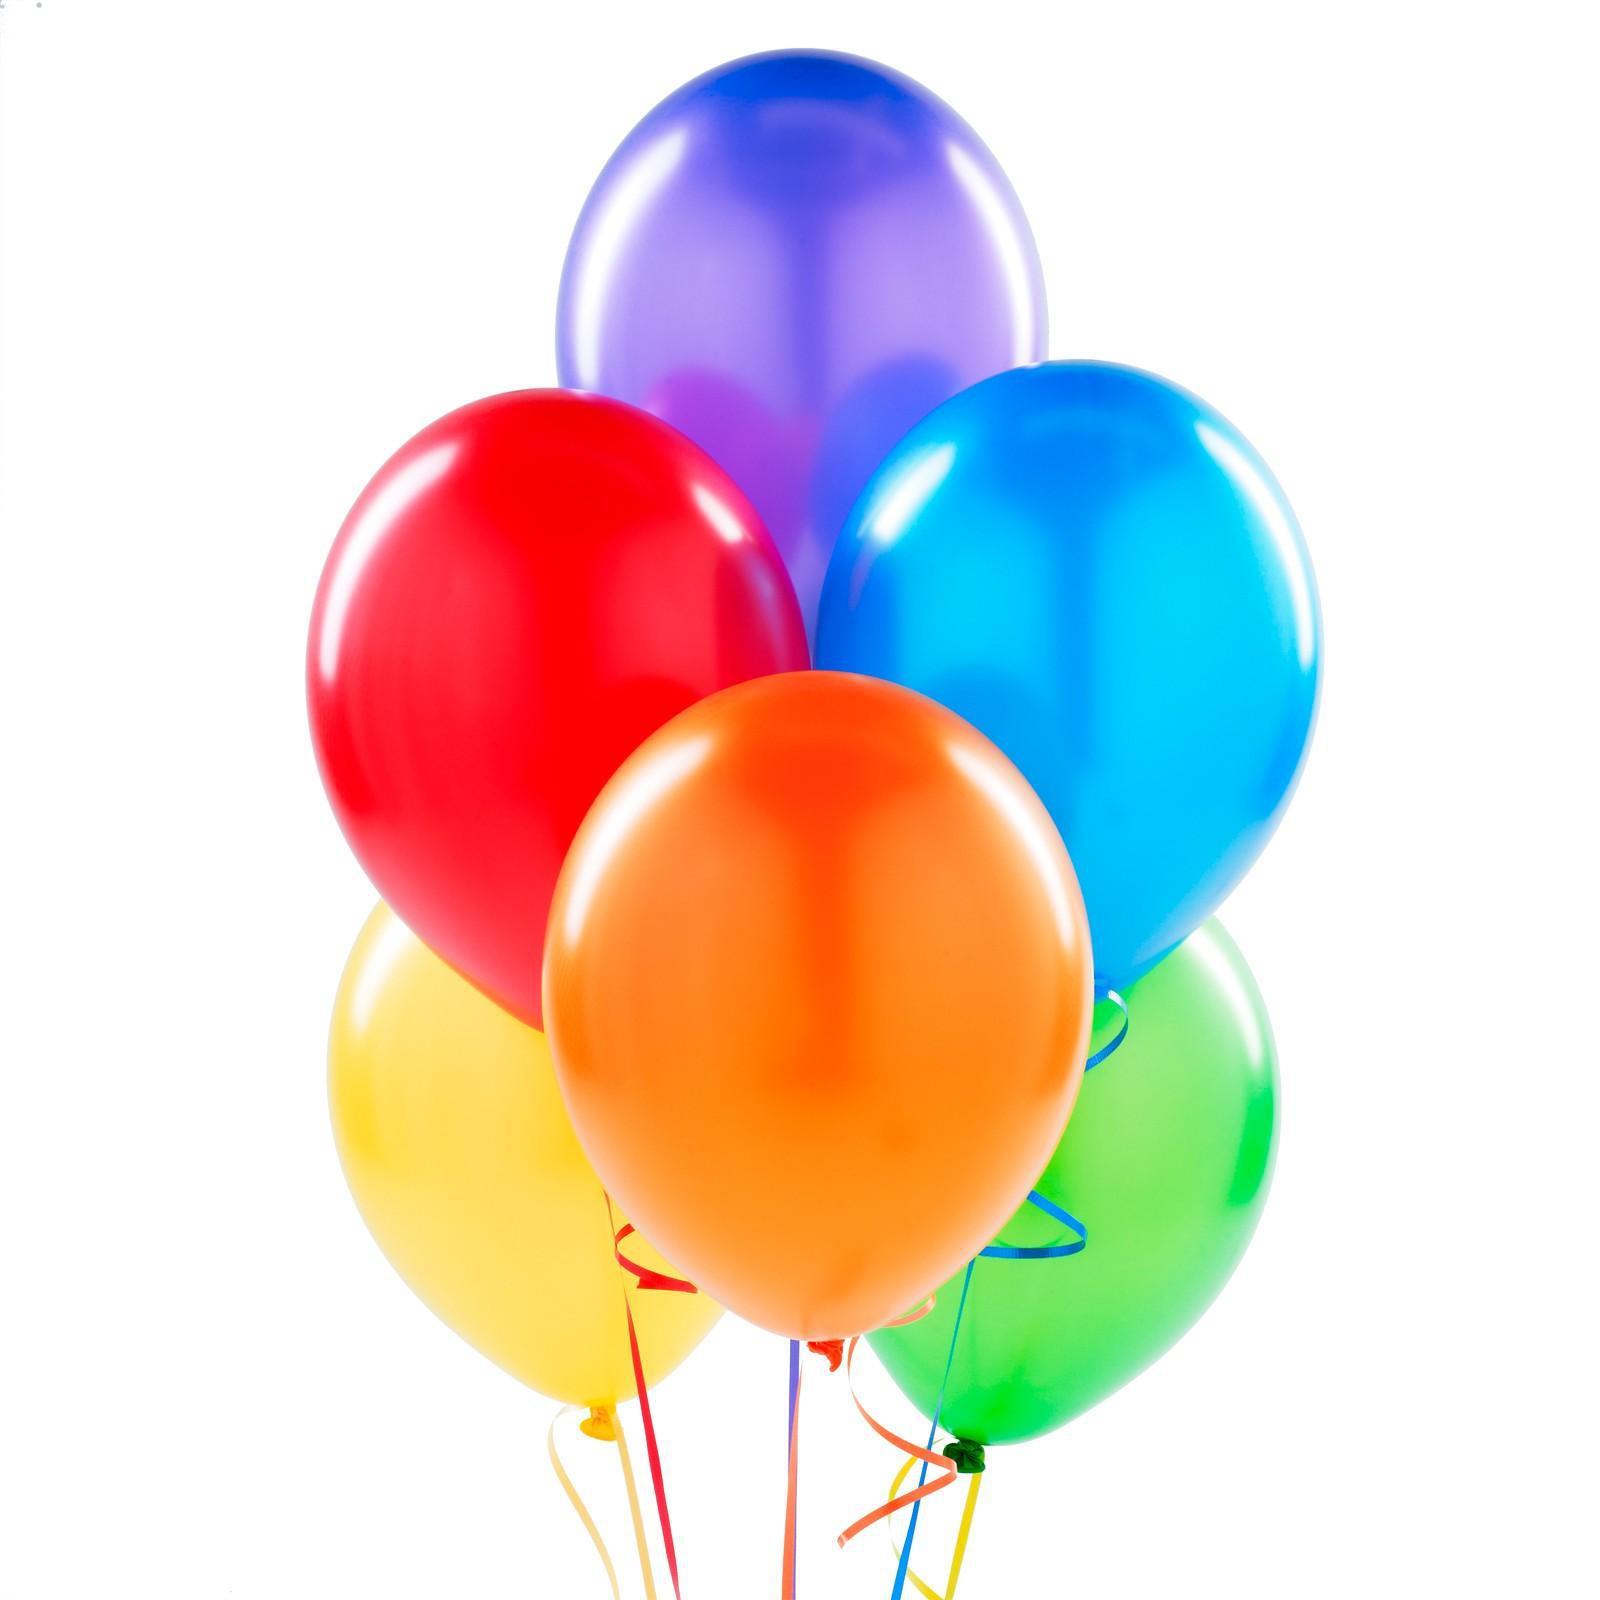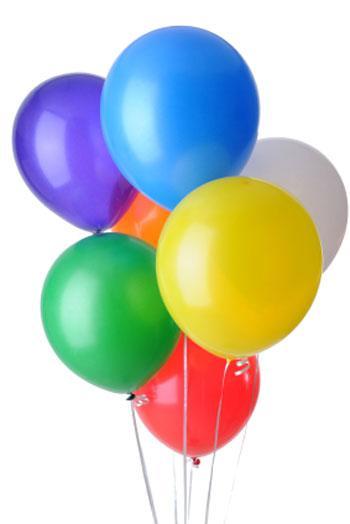The first image is the image on the left, the second image is the image on the right. Analyze the images presented: Is the assertion "Each image shows one bunch of different colored balloons with strings hanging down, and no bunch contains more than 10 balloons." valid? Answer yes or no. Yes. The first image is the image on the left, the second image is the image on the right. Examine the images to the left and right. Is the description "In at least one image there are six different colored balloons." accurate? Answer yes or no. Yes. 